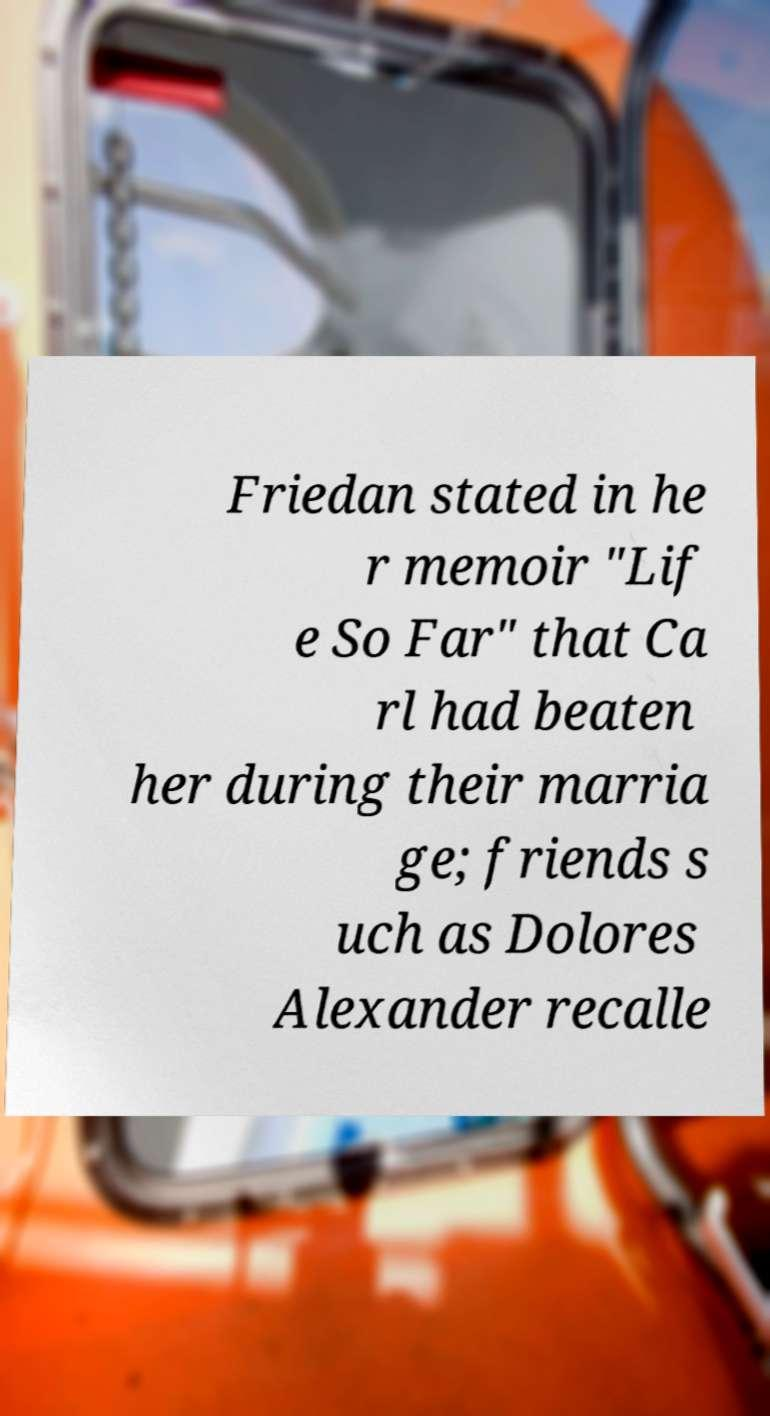Please read and relay the text visible in this image. What does it say? Friedan stated in he r memoir "Lif e So Far" that Ca rl had beaten her during their marria ge; friends s uch as Dolores Alexander recalle 